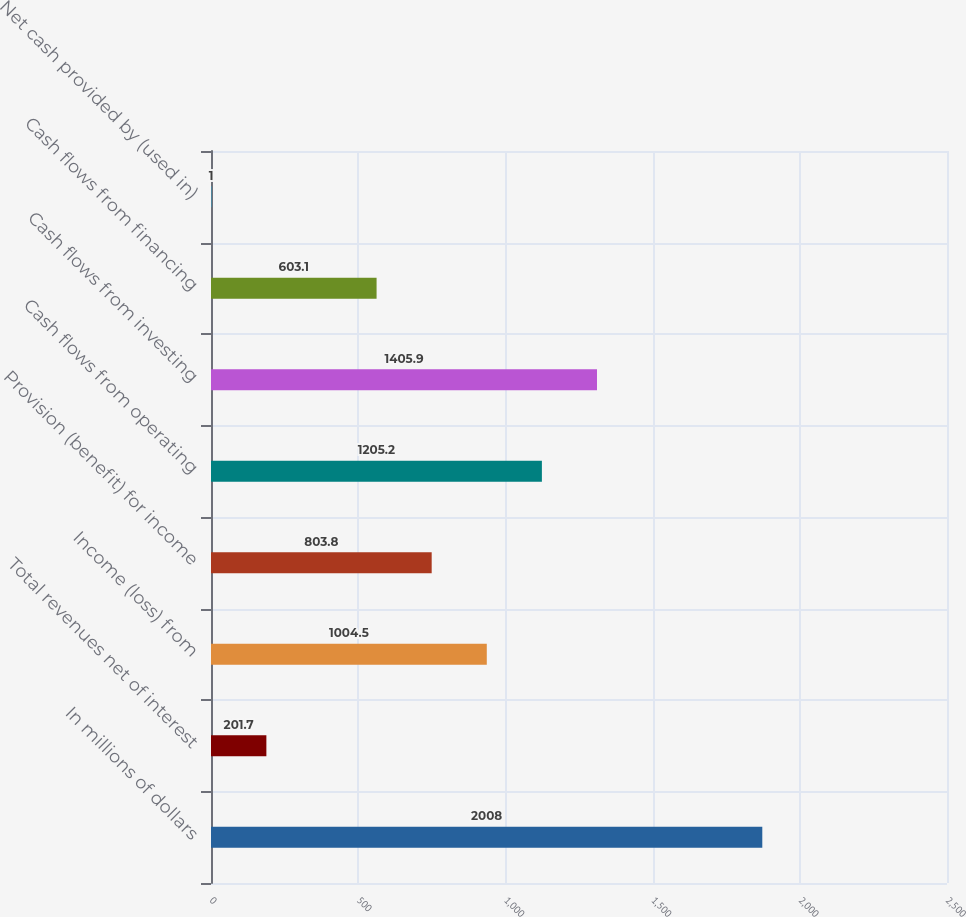Convert chart to OTSL. <chart><loc_0><loc_0><loc_500><loc_500><bar_chart><fcel>In millions of dollars<fcel>Total revenues net of interest<fcel>Income (loss) from<fcel>Provision (benefit) for income<fcel>Cash flows from operating<fcel>Cash flows from investing<fcel>Cash flows from financing<fcel>Net cash provided by (used in)<nl><fcel>2008<fcel>201.7<fcel>1004.5<fcel>803.8<fcel>1205.2<fcel>1405.9<fcel>603.1<fcel>1<nl></chart> 